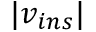Convert formula to latex. <formula><loc_0><loc_0><loc_500><loc_500>| v _ { i n s } |</formula> 